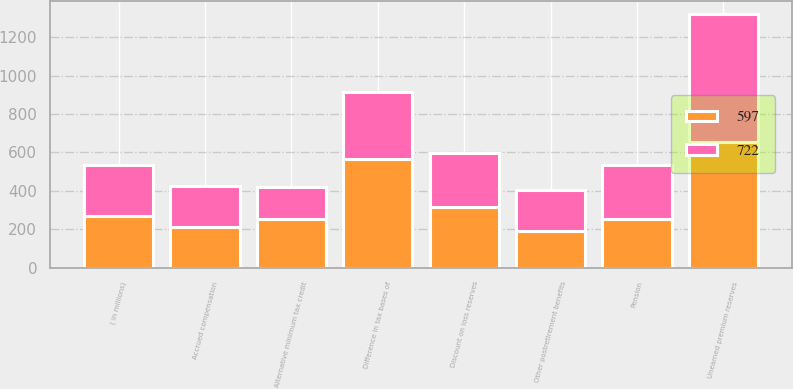Convert chart to OTSL. <chart><loc_0><loc_0><loc_500><loc_500><stacked_bar_chart><ecel><fcel>( in millions)<fcel>Unearned premium reserves<fcel>Difference in tax bases of<fcel>Discount on loss reserves<fcel>Pension<fcel>Other postretirement benefits<fcel>Accrued compensation<fcel>Alternative minimum tax credit<nl><fcel>722<fcel>266.5<fcel>666<fcel>353<fcel>280<fcel>278<fcel>218<fcel>212<fcel>165<nl><fcel>597<fcel>266.5<fcel>656<fcel>564<fcel>315<fcel>255<fcel>188<fcel>213<fcel>255<nl></chart> 